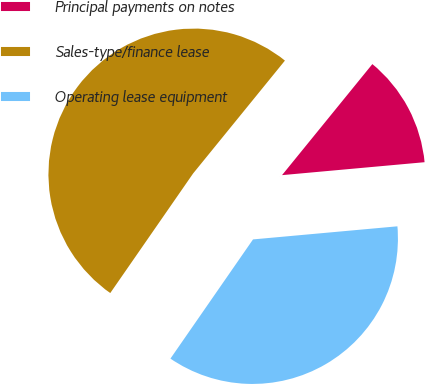Convert chart to OTSL. <chart><loc_0><loc_0><loc_500><loc_500><pie_chart><fcel>Principal payments on notes<fcel>Sales-type/finance lease<fcel>Operating lease equipment<nl><fcel>12.69%<fcel>51.22%<fcel>36.08%<nl></chart> 